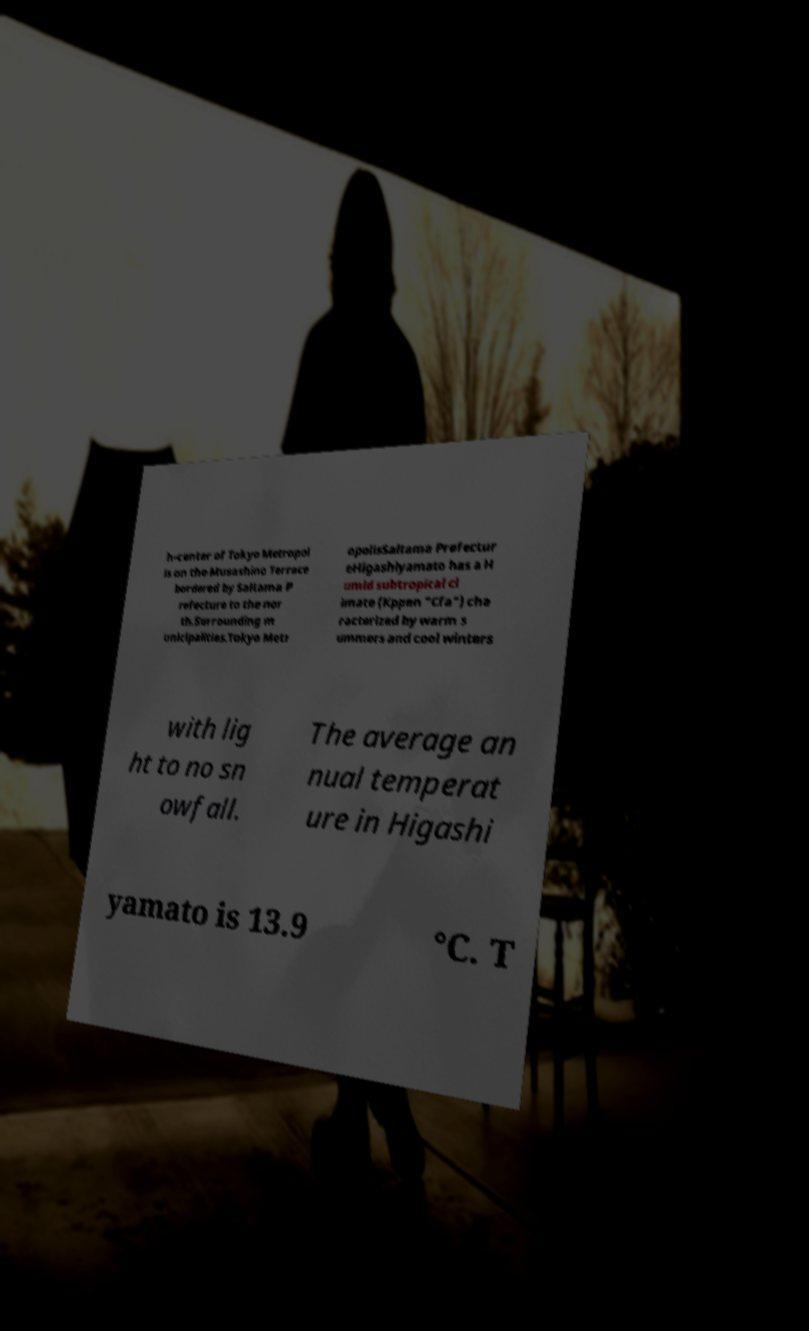Could you assist in decoding the text presented in this image and type it out clearly? h-center of Tokyo Metropol is on the Musashino Terrace bordered by Saitama P refecture to the nor th.Surrounding m unicipalities.Tokyo Metr opolisSaitama Prefectur eHigashiyamato has a H umid subtropical cl imate (Kppen "Cfa") cha racterized by warm s ummers and cool winters with lig ht to no sn owfall. The average an nual temperat ure in Higashi yamato is 13.9 °C. T 